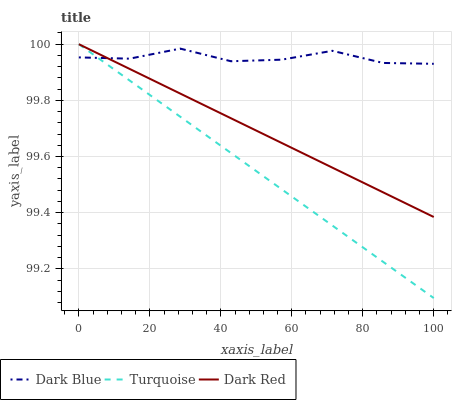Does Turquoise have the minimum area under the curve?
Answer yes or no. Yes. Does Dark Blue have the maximum area under the curve?
Answer yes or no. Yes. Does Dark Red have the minimum area under the curve?
Answer yes or no. No. Does Dark Red have the maximum area under the curve?
Answer yes or no. No. Is Turquoise the smoothest?
Answer yes or no. Yes. Is Dark Blue the roughest?
Answer yes or no. Yes. Is Dark Red the smoothest?
Answer yes or no. No. Is Dark Red the roughest?
Answer yes or no. No. Does Turquoise have the lowest value?
Answer yes or no. Yes. Does Dark Red have the lowest value?
Answer yes or no. No. Does Dark Red have the highest value?
Answer yes or no. Yes. Does Dark Red intersect Dark Blue?
Answer yes or no. Yes. Is Dark Red less than Dark Blue?
Answer yes or no. No. Is Dark Red greater than Dark Blue?
Answer yes or no. No. 